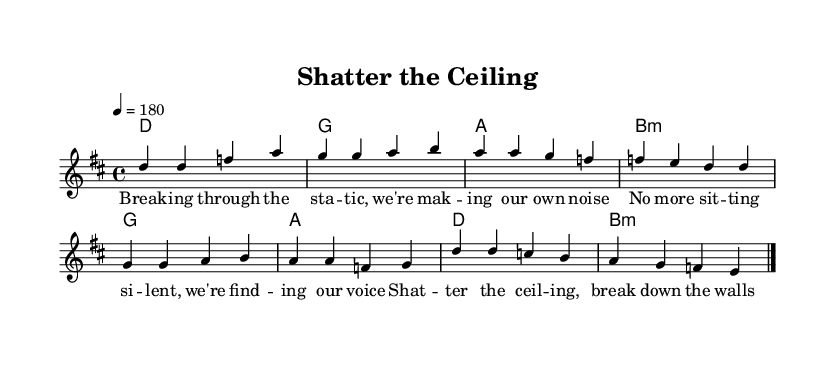What is the key signature of this music? The key signature is D major, which has two sharps (F# and C#).
Answer: D major What is the time signature of this music? The time signature is 4/4, indicating four beats per measure.
Answer: 4/4 What is the tempo marking in this piece? The tempo marking is indicated as '4 = 180', meaning there are 180 beats per minute.
Answer: 180 What are the lyrics of the chorus? The lyrics of the chorus are "Shatter the ceiling, break down the walls / We're here to stay, watch as it falls." These lyrics are displayed under the melody labeled as the chorus.
Answer: Shatter the ceiling, break down the walls / We're here to stay, watch as it falls How many measures are in the voice part? The voice part consists of two sections: the verse and the chorus. There are a total of 8 measures in the voice part (4 measures for the verse and 4 for the chorus).
Answer: 8 What chords are used in the verse? The chords used in the verse are D, G, A, and B minor. These chords are displayed above the corresponding melody notes.
Answer: D, G, A, B minor What is the general theme of the lyrics? The lyrics express empowerment and breaking barriers, a common theme in punk music, emphasizing taking a stance and finding one's voice.
Answer: Empowerment and breaking barriers 